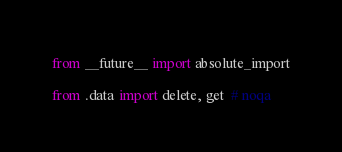Convert code to text. <code><loc_0><loc_0><loc_500><loc_500><_Python_>from __future__ import absolute_import

from .data import delete, get  # noqa
</code> 